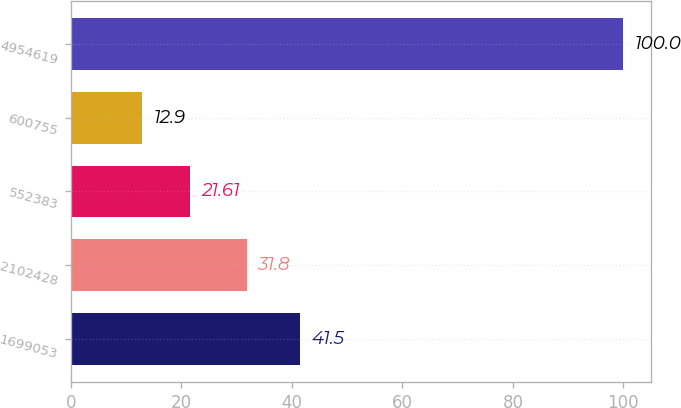<chart> <loc_0><loc_0><loc_500><loc_500><bar_chart><fcel>1699053<fcel>2102428<fcel>552383<fcel>600755<fcel>4954619<nl><fcel>41.5<fcel>31.8<fcel>21.61<fcel>12.9<fcel>100<nl></chart> 